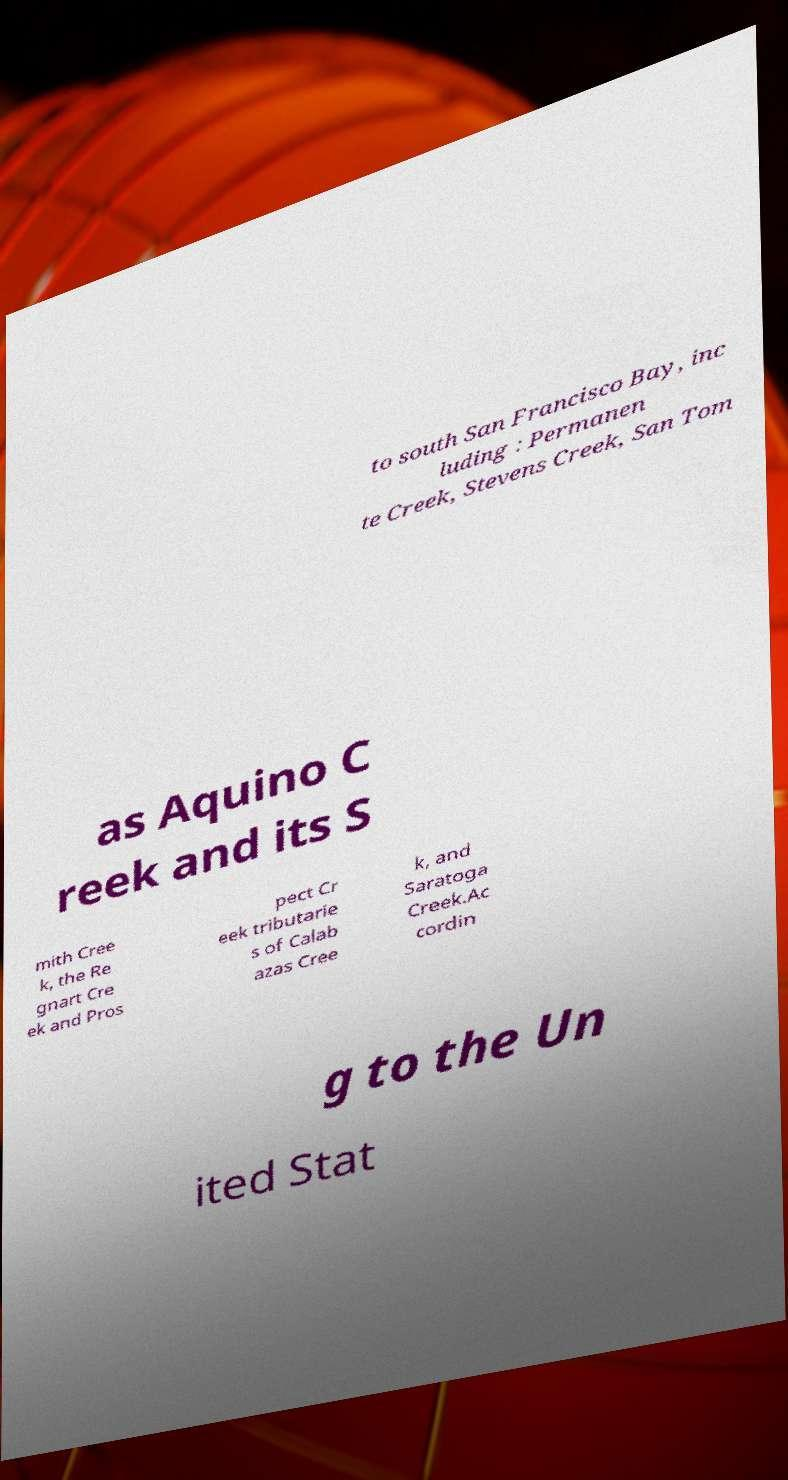Could you extract and type out the text from this image? to south San Francisco Bay, inc luding : Permanen te Creek, Stevens Creek, San Tom as Aquino C reek and its S mith Cree k, the Re gnart Cre ek and Pros pect Cr eek tributarie s of Calab azas Cree k, and Saratoga Creek.Ac cordin g to the Un ited Stat 